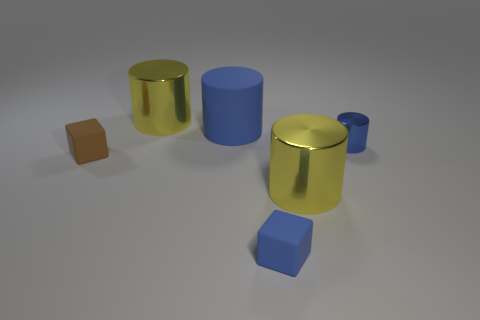Could you describe the lighting in the scene? The lighting in the scene is soft and seems to be coming from the upper left side, creating gentle shadows to the right of the objects which help to enhance their three-dimensional form. 